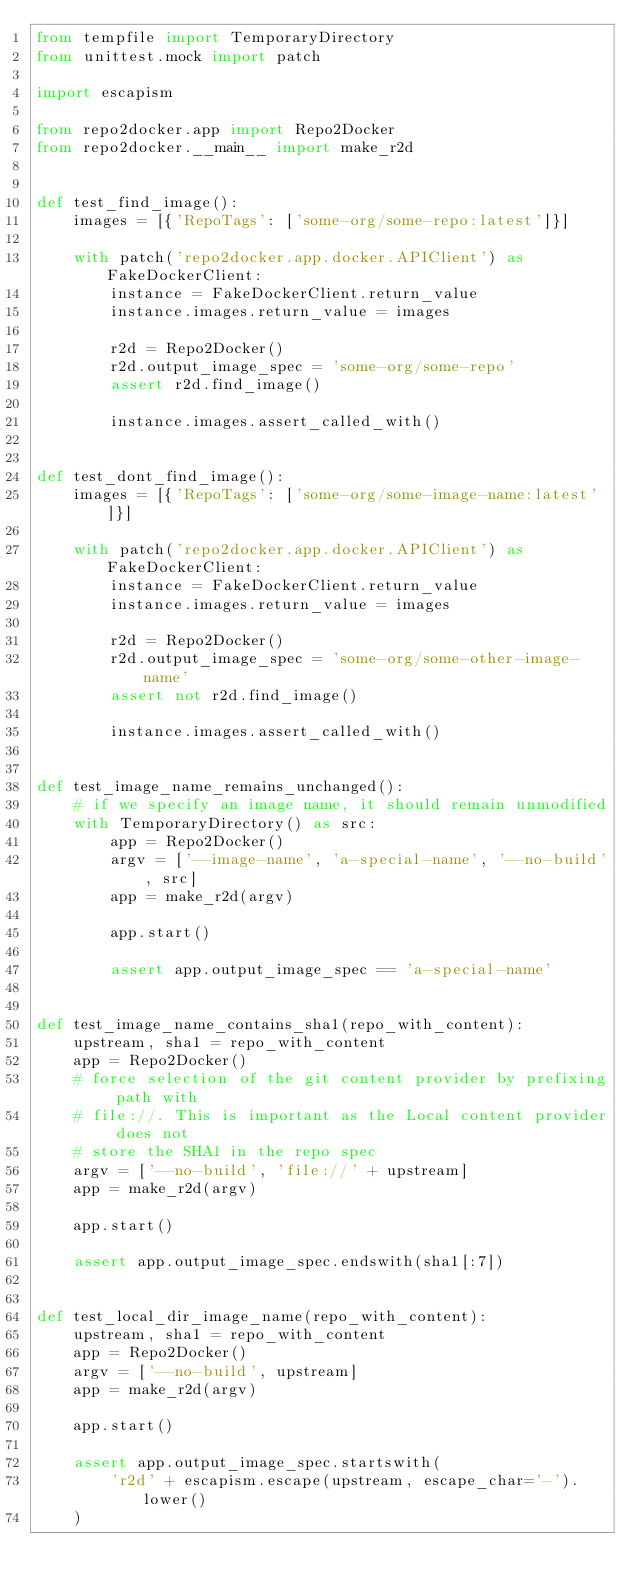Convert code to text. <code><loc_0><loc_0><loc_500><loc_500><_Python_>from tempfile import TemporaryDirectory
from unittest.mock import patch

import escapism

from repo2docker.app import Repo2Docker
from repo2docker.__main__ import make_r2d


def test_find_image():
    images = [{'RepoTags': ['some-org/some-repo:latest']}]

    with patch('repo2docker.app.docker.APIClient') as FakeDockerClient:
        instance = FakeDockerClient.return_value
        instance.images.return_value = images

        r2d = Repo2Docker()
        r2d.output_image_spec = 'some-org/some-repo'
        assert r2d.find_image()

        instance.images.assert_called_with()


def test_dont_find_image():
    images = [{'RepoTags': ['some-org/some-image-name:latest']}]

    with patch('repo2docker.app.docker.APIClient') as FakeDockerClient:
        instance = FakeDockerClient.return_value
        instance.images.return_value = images

        r2d = Repo2Docker()
        r2d.output_image_spec = 'some-org/some-other-image-name'
        assert not r2d.find_image()

        instance.images.assert_called_with()


def test_image_name_remains_unchanged():
    # if we specify an image name, it should remain unmodified
    with TemporaryDirectory() as src:
        app = Repo2Docker()
        argv = ['--image-name', 'a-special-name', '--no-build', src]
        app = make_r2d(argv)

        app.start()

        assert app.output_image_spec == 'a-special-name'


def test_image_name_contains_sha1(repo_with_content):
    upstream, sha1 = repo_with_content
    app = Repo2Docker()
    # force selection of the git content provider by prefixing path with
    # file://. This is important as the Local content provider does not
    # store the SHA1 in the repo spec
    argv = ['--no-build', 'file://' + upstream]
    app = make_r2d(argv)

    app.start()

    assert app.output_image_spec.endswith(sha1[:7])


def test_local_dir_image_name(repo_with_content):
    upstream, sha1 = repo_with_content
    app = Repo2Docker()
    argv = ['--no-build', upstream]
    app = make_r2d(argv)

    app.start()

    assert app.output_image_spec.startswith(
        'r2d' + escapism.escape(upstream, escape_char='-').lower()
    )
</code> 